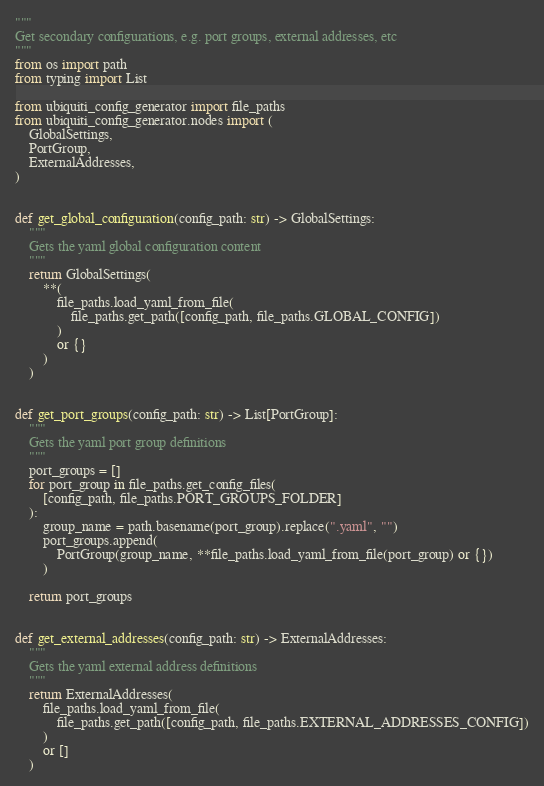<code> <loc_0><loc_0><loc_500><loc_500><_Python_>"""
Get secondary configurations, e.g. port groups, external addresses, etc
"""
from os import path
from typing import List

from ubiquiti_config_generator import file_paths
from ubiquiti_config_generator.nodes import (
    GlobalSettings,
    PortGroup,
    ExternalAddresses,
)


def get_global_configuration(config_path: str) -> GlobalSettings:
    """
    Gets the yaml global configuration content
    """
    return GlobalSettings(
        **(
            file_paths.load_yaml_from_file(
                file_paths.get_path([config_path, file_paths.GLOBAL_CONFIG])
            )
            or {}
        )
    )


def get_port_groups(config_path: str) -> List[PortGroup]:
    """
    Gets the yaml port group definitions
    """
    port_groups = []
    for port_group in file_paths.get_config_files(
        [config_path, file_paths.PORT_GROUPS_FOLDER]
    ):
        group_name = path.basename(port_group).replace(".yaml", "")
        port_groups.append(
            PortGroup(group_name, **file_paths.load_yaml_from_file(port_group) or {})
        )

    return port_groups


def get_external_addresses(config_path: str) -> ExternalAddresses:
    """
    Gets the yaml external address definitions
    """
    return ExternalAddresses(
        file_paths.load_yaml_from_file(
            file_paths.get_path([config_path, file_paths.EXTERNAL_ADDRESSES_CONFIG])
        )
        or []
    )
</code> 